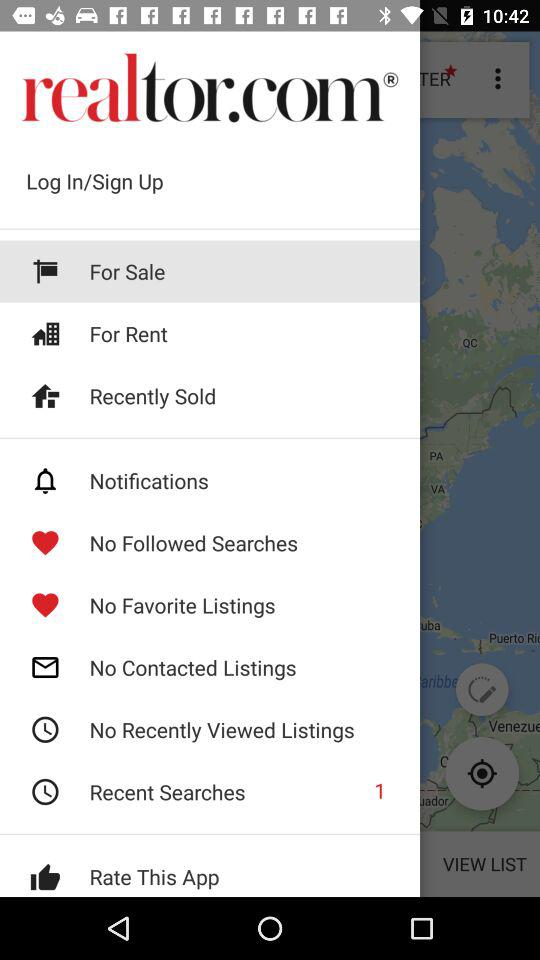Which option is selected? The selected option is "For Sale". 